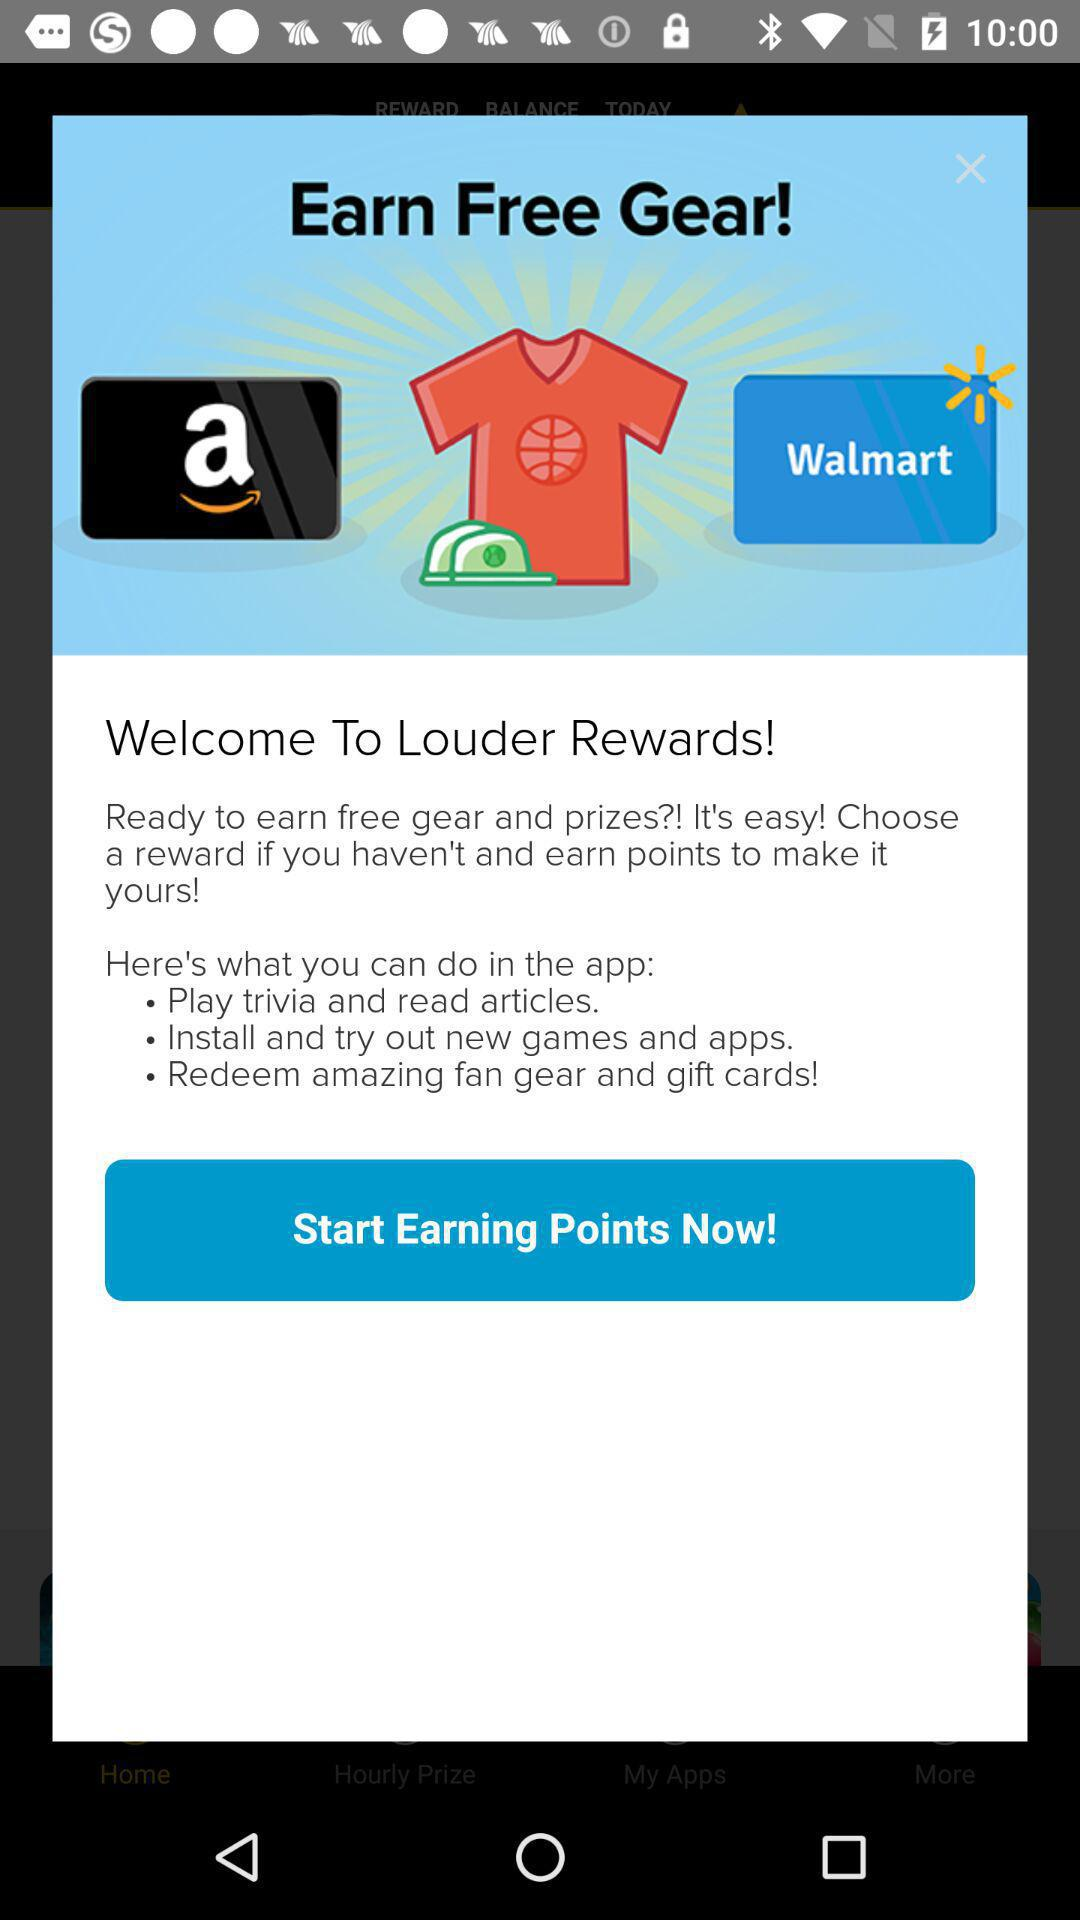How many rewards are available?
Answer the question using a single word or phrase. 2 